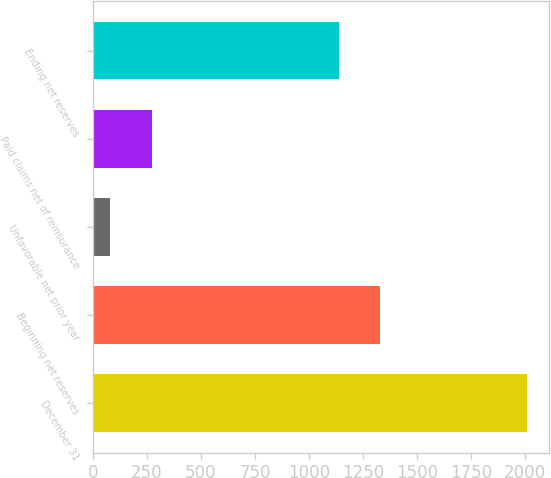<chart> <loc_0><loc_0><loc_500><loc_500><bar_chart><fcel>December 31<fcel>Beginning net reserves<fcel>Unfavorable net prior year<fcel>Paid claims net of reinsurance<fcel>Ending net reserves<nl><fcel>2009<fcel>1330<fcel>79<fcel>272<fcel>1137<nl></chart> 